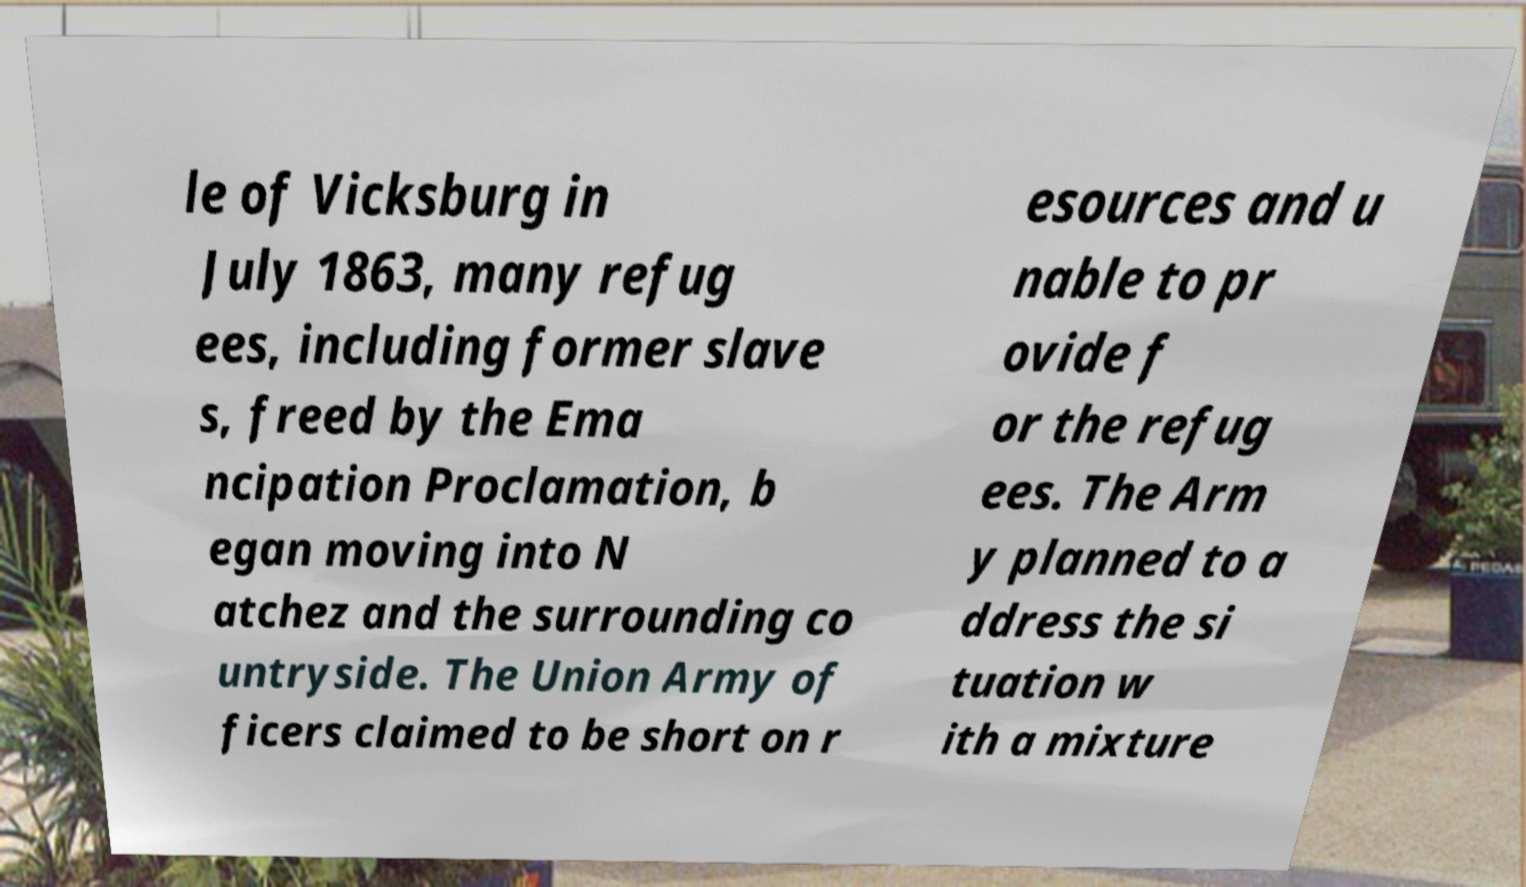Please identify and transcribe the text found in this image. le of Vicksburg in July 1863, many refug ees, including former slave s, freed by the Ema ncipation Proclamation, b egan moving into N atchez and the surrounding co untryside. The Union Army of ficers claimed to be short on r esources and u nable to pr ovide f or the refug ees. The Arm y planned to a ddress the si tuation w ith a mixture 